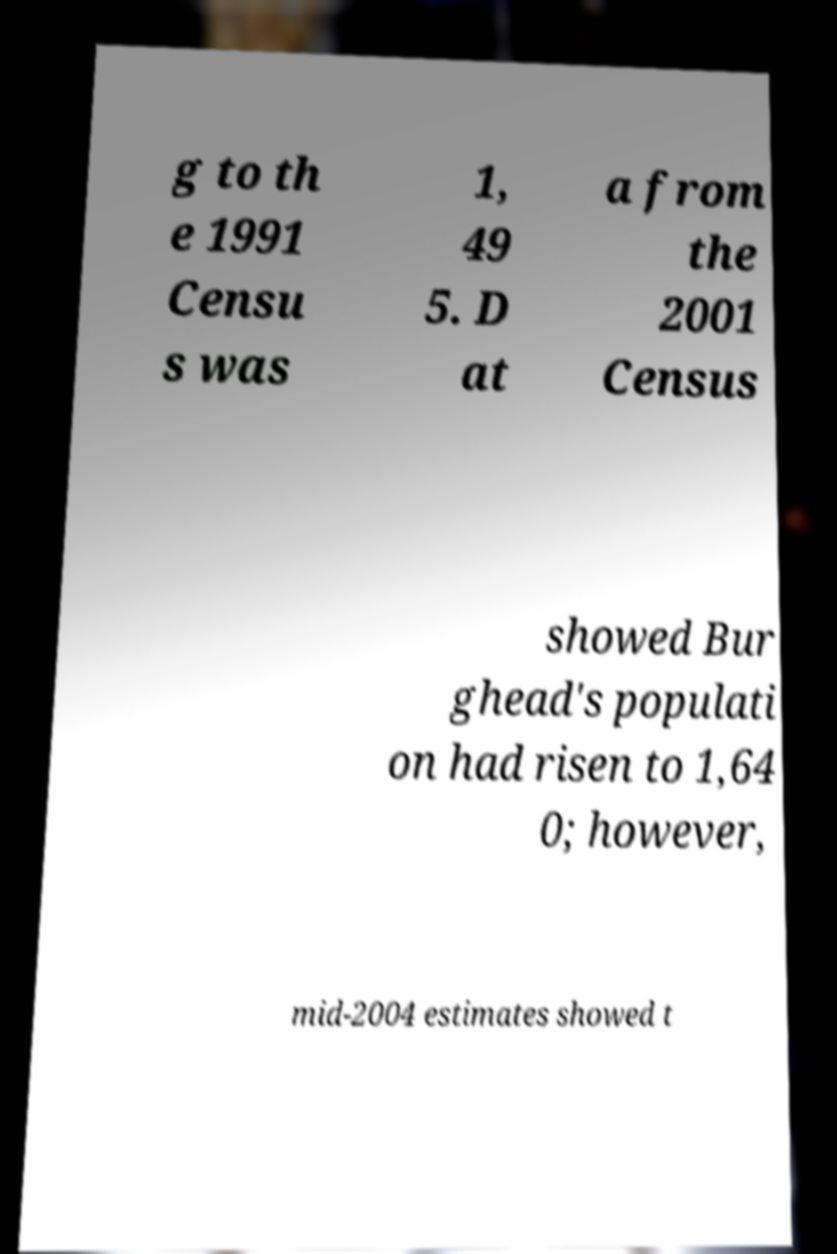What messages or text are displayed in this image? I need them in a readable, typed format. g to th e 1991 Censu s was 1, 49 5. D at a from the 2001 Census showed Bur ghead's populati on had risen to 1,64 0; however, mid-2004 estimates showed t 